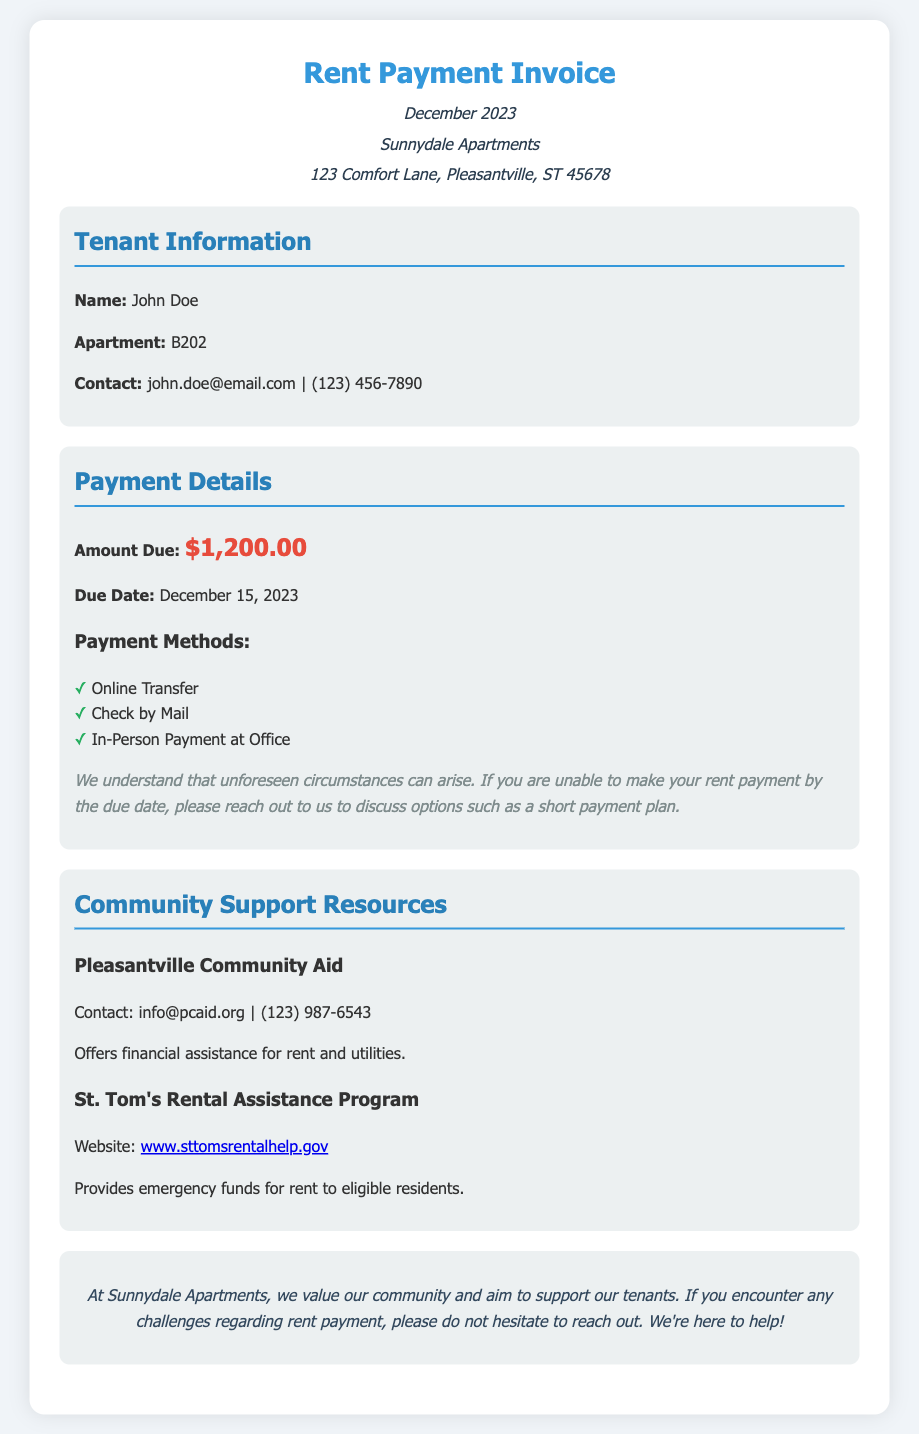What is the amount due for December 2023? The amount due is mentioned explicitly in the payment details section.
Answer: $1,200.00 What is the due date for the rent payment? The due date is stated in the payment details section.
Answer: December 15, 2023 What are the payment methods listed? The payment methods are outlined in the payment details section.
Answer: Online Transfer, Check by Mail, In-Person Payment at Office What community support resource offers financial assistance for rent? This information is found in the community support resources section.
Answer: Pleasantville Community Aid What should tenants do if they cannot make the rent payment by the due date? This is specified in the flexibility options part of the payment details section.
Answer: Reach out to discuss options What is the contact email for Pleasantville Community Aid? This is provided in the community support resources section.
Answer: info@pcaid.org How does Sunnydale Apartments prioritize tenant relations? This is explained in the closing remarks, indicating their approach.
Answer: Support and community value What kind of assistance does St. Tom's Rental Assistance Program provide? The type of assistance is detailed in the support resources section.
Answer: Emergency funds for rent 